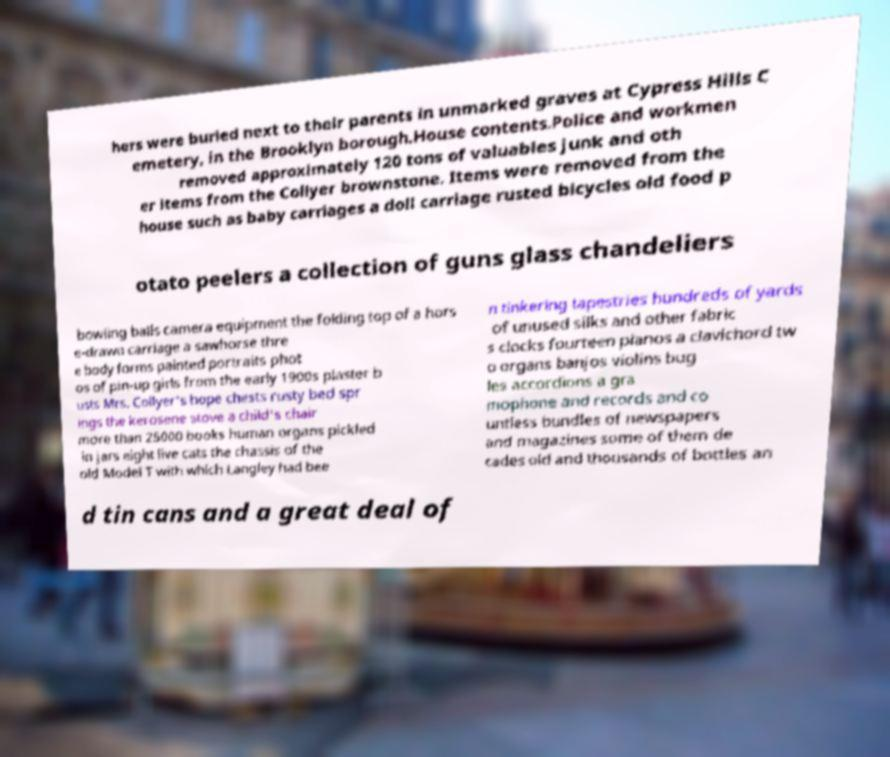Could you extract and type out the text from this image? hers were buried next to their parents in unmarked graves at Cypress Hills C emetery, in the Brooklyn borough.House contents.Police and workmen removed approximately 120 tons of valuables junk and oth er items from the Collyer brownstone. Items were removed from the house such as baby carriages a doll carriage rusted bicycles old food p otato peelers a collection of guns glass chandeliers bowling balls camera equipment the folding top of a hors e-drawn carriage a sawhorse thre e body forms painted portraits phot os of pin-up girls from the early 1900s plaster b usts Mrs. Collyer's hope chests rusty bed spr ings the kerosene stove a child's chair more than 25000 books human organs pickled in jars eight live cats the chassis of the old Model T with which Langley had bee n tinkering tapestries hundreds of yards of unused silks and other fabric s clocks fourteen pianos a clavichord tw o organs banjos violins bug les accordions a gra mophone and records and co untless bundles of newspapers and magazines some of them de cades old and thousands of bottles an d tin cans and a great deal of 